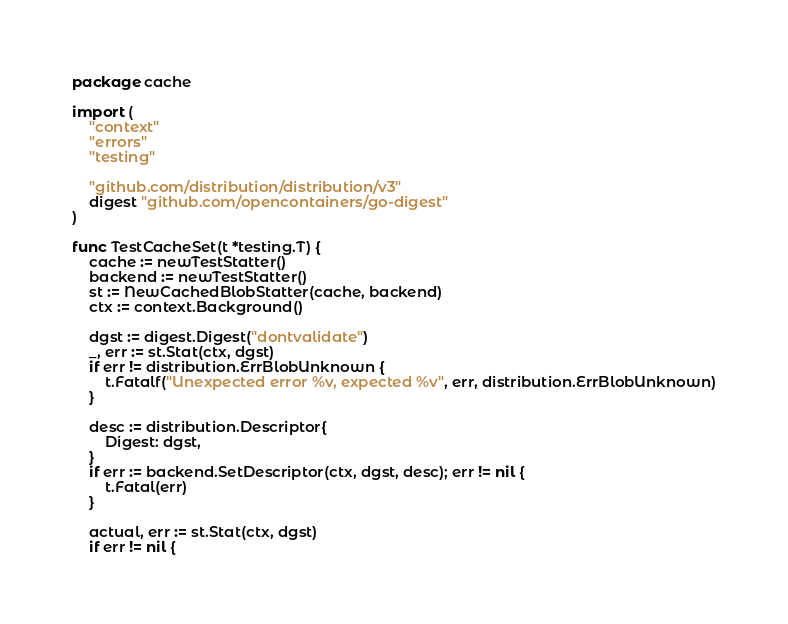Convert code to text. <code><loc_0><loc_0><loc_500><loc_500><_Go_>package cache

import (
	"context"
	"errors"
	"testing"

	"github.com/distribution/distribution/v3"
	digest "github.com/opencontainers/go-digest"
)

func TestCacheSet(t *testing.T) {
	cache := newTestStatter()
	backend := newTestStatter()
	st := NewCachedBlobStatter(cache, backend)
	ctx := context.Background()

	dgst := digest.Digest("dontvalidate")
	_, err := st.Stat(ctx, dgst)
	if err != distribution.ErrBlobUnknown {
		t.Fatalf("Unexpected error %v, expected %v", err, distribution.ErrBlobUnknown)
	}

	desc := distribution.Descriptor{
		Digest: dgst,
	}
	if err := backend.SetDescriptor(ctx, dgst, desc); err != nil {
		t.Fatal(err)
	}

	actual, err := st.Stat(ctx, dgst)
	if err != nil {</code> 